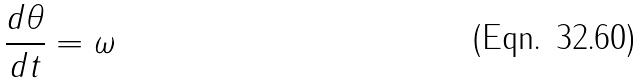<formula> <loc_0><loc_0><loc_500><loc_500>\frac { d \theta } { d t } = \omega</formula> 